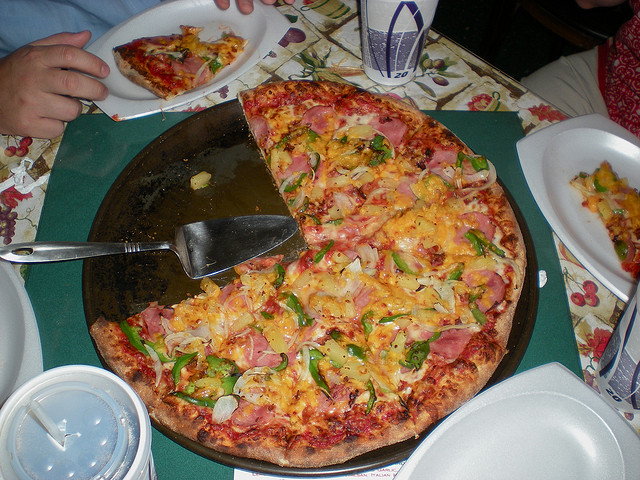Identify and read out the text in this image. ZO 